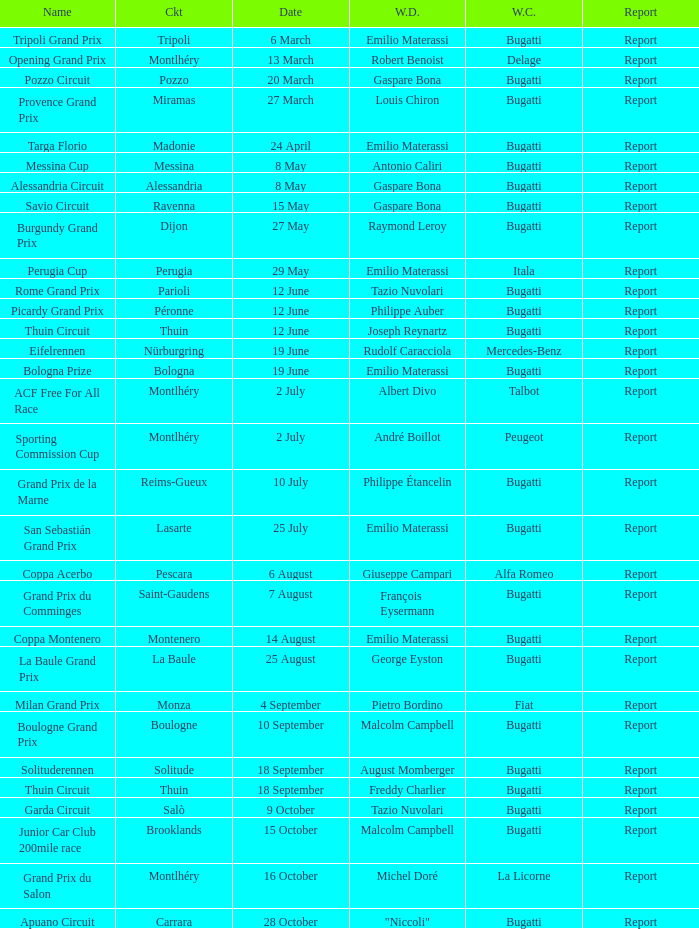Could you help me parse every detail presented in this table? {'header': ['Name', 'Ckt', 'Date', 'W.D.', 'W.C.', 'Report'], 'rows': [['Tripoli Grand Prix', 'Tripoli', '6 March', 'Emilio Materassi', 'Bugatti', 'Report'], ['Opening Grand Prix', 'Montlhéry', '13 March', 'Robert Benoist', 'Delage', 'Report'], ['Pozzo Circuit', 'Pozzo', '20 March', 'Gaspare Bona', 'Bugatti', 'Report'], ['Provence Grand Prix', 'Miramas', '27 March', 'Louis Chiron', 'Bugatti', 'Report'], ['Targa Florio', 'Madonie', '24 April', 'Emilio Materassi', 'Bugatti', 'Report'], ['Messina Cup', 'Messina', '8 May', 'Antonio Caliri', 'Bugatti', 'Report'], ['Alessandria Circuit', 'Alessandria', '8 May', 'Gaspare Bona', 'Bugatti', 'Report'], ['Savio Circuit', 'Ravenna', '15 May', 'Gaspare Bona', 'Bugatti', 'Report'], ['Burgundy Grand Prix', 'Dijon', '27 May', 'Raymond Leroy', 'Bugatti', 'Report'], ['Perugia Cup', 'Perugia', '29 May', 'Emilio Materassi', 'Itala', 'Report'], ['Rome Grand Prix', 'Parioli', '12 June', 'Tazio Nuvolari', 'Bugatti', 'Report'], ['Picardy Grand Prix', 'Péronne', '12 June', 'Philippe Auber', 'Bugatti', 'Report'], ['Thuin Circuit', 'Thuin', '12 June', 'Joseph Reynartz', 'Bugatti', 'Report'], ['Eifelrennen', 'Nürburgring', '19 June', 'Rudolf Caracciola', 'Mercedes-Benz', 'Report'], ['Bologna Prize', 'Bologna', '19 June', 'Emilio Materassi', 'Bugatti', 'Report'], ['ACF Free For All Race', 'Montlhéry', '2 July', 'Albert Divo', 'Talbot', 'Report'], ['Sporting Commission Cup', 'Montlhéry', '2 July', 'André Boillot', 'Peugeot', 'Report'], ['Grand Prix de la Marne', 'Reims-Gueux', '10 July', 'Philippe Étancelin', 'Bugatti', 'Report'], ['San Sebastián Grand Prix', 'Lasarte', '25 July', 'Emilio Materassi', 'Bugatti', 'Report'], ['Coppa Acerbo', 'Pescara', '6 August', 'Giuseppe Campari', 'Alfa Romeo', 'Report'], ['Grand Prix du Comminges', 'Saint-Gaudens', '7 August', 'François Eysermann', 'Bugatti', 'Report'], ['Coppa Montenero', 'Montenero', '14 August', 'Emilio Materassi', 'Bugatti', 'Report'], ['La Baule Grand Prix', 'La Baule', '25 August', 'George Eyston', 'Bugatti', 'Report'], ['Milan Grand Prix', 'Monza', '4 September', 'Pietro Bordino', 'Fiat', 'Report'], ['Boulogne Grand Prix', 'Boulogne', '10 September', 'Malcolm Campbell', 'Bugatti', 'Report'], ['Solituderennen', 'Solitude', '18 September', 'August Momberger', 'Bugatti', 'Report'], ['Thuin Circuit', 'Thuin', '18 September', 'Freddy Charlier', 'Bugatti', 'Report'], ['Garda Circuit', 'Salò', '9 October', 'Tazio Nuvolari', 'Bugatti', 'Report'], ['Junior Car Club 200mile race', 'Brooklands', '15 October', 'Malcolm Campbell', 'Bugatti', 'Report'], ['Grand Prix du Salon', 'Montlhéry', '16 October', 'Michel Doré', 'La Licorne', 'Report'], ['Apuano Circuit', 'Carrara', '28 October', '"Niccoli"', 'Bugatti', 'Report']]} Which circuit did françois eysermann win ? Saint-Gaudens. 